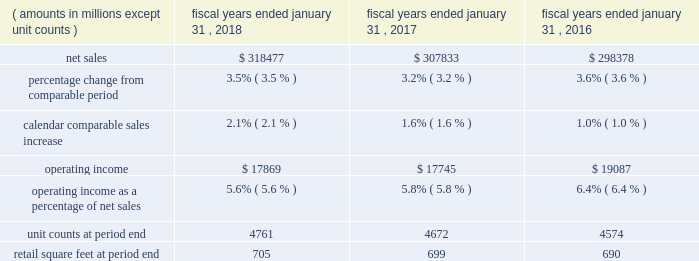Continued investments in ecommerce and technology .
The increase in operating expenses as a percentage of net sales for fiscal 2017 was partially offset by the impact of store closures in the fourth quarter of fiscal 2016 .
Membership and other income was relatively flat for fiscal 2018 and increased $ 1.0 billion a0for fiscal 2017 , when compared to the same period in the previous fiscal year .
While fiscal 2018 included a $ 387 million gain from the sale of suburbia , a $ 47 million gain from a land sale , higher recycling income from our sustainability efforts and higher membership income from increased plus member penetration at sam's club , these gains were less than gains recognized in fiscal 2017 .
Fiscal 2017 included a $ 535 million gain from the sale of our yihaodian business and a $ 194 million gain from the sale of shopping malls in chile .
For fiscal 2018 , loss on extinguishment of debt was a0$ 3.1 billion , due to the early extinguishment of long-term debt which allowed us to retire higher rate debt to reduce interest expense in future periods .
Our effective income tax rate was 30.4% ( 30.4 % ) for fiscal 2018 and 30.3% ( 30.3 % ) for both fiscal 2017 and 2016 .
Although relatively consistent year-over-year , our effective income tax rate may fluctuate from period to period as a result of factors including changes in our assessment of certain tax contingencies , valuation allowances , changes in tax laws , outcomes of administrative audits , the impact of discrete items and the mix of earnings among our u.s .
Operations and international operations .
The reconciliation from the u.s .
Statutory rate to the effective income tax rates for fiscal 2018 , 2017 and 2016 is presented in note 9 in the "notes to consolidated financial statements" and describes the impact of the enactment of the tax cuts and jobs act of 2017 ( the "tax act" ) to the fiscal 2018 effective income tax rate .
As a result of the factors discussed above , we reported $ 10.5 billion and $ 14.3 billion of consolidated net income for fiscal 2018 and 2017 , respectively , which represents a decrease of $ 3.8 billion and $ 0.8 billion for fiscal 2018 and 2017 , respectively , when compared to the previous fiscal year .
Diluted net income per common share attributable to walmart ( "eps" ) was $ 3.28 and $ 4.38 for fiscal 2018 and 2017 , respectively .
Walmart u.s .
Segment .
Net sales for the walmart u.s .
Segment increased $ 10.6 billion or 3.5% ( 3.5 % ) and $ 9.5 billion or 3.2% ( 3.2 % ) for fiscal 2018 and 2017 , respectively , when compared to the previous fiscal year .
The increases in net sales were primarily due to increases in comparable store sales of 2.1% ( 2.1 % ) and 1.6% ( 1.6 % ) for fiscal 2018 and 2017 , respectively , and year-over-year growth in retail square feet of 0.7% ( 0.7 % ) and 1.4% ( 1.4 % ) for fiscal 2018 and 2017 , respectively .
Additionally , for fiscal 2018 , sales generated from ecommerce acquisitions further contributed to the year-over-year increase .
Gross profit rate decreased 24 basis points for fiscal 2018 and increased 24 basis points for fiscal 2017 , when compared to the previous fiscal year .
For fiscal 2018 , the decrease was primarily due to strategic price investments and the mix impact from ecommerce .
Partially offsetting the negative factors for fiscal 2018 was the positive impact of savings from procuring merchandise .
For fiscal 2017 , the increase in gross profit rate was primarily due to improved margin in food and consumables , including the impact of savings in procuring merchandise and lower transportation expense from lower fuel costs .
Operating expenses as a percentage of segment net sales was relatively flat for fiscal 2018 and increased 101 basis points for fiscal 2017 , when compared to the previous fiscal year .
Fiscal 2018 and fiscal 2017 included charges related to discontinued real estate projects of $ 244 million and $ 249 million , respectively .
For fiscal 2017 , the increase was primarily driven by an increase in wage expense due to the investment in the associate wage structure ; the charge related to discontinued real estate projects ; and investments in digital retail and technology .
The increase in operating expenses as a percentage of segment net sales for fiscal 2017 was partially offset by the impact of store closures in fiscal 2016 .
As a result of the factors discussed above , segment operating income increased $ 124 million for fiscal 2018 and decreased $ 1.3 billion for fiscal 2017 , respectively. .
What is the growth rate in net sales for walmart u.s . segment from 2017 to 2018? 
Computations: ((318477 - 307833) / 307833)
Answer: 0.03458. 